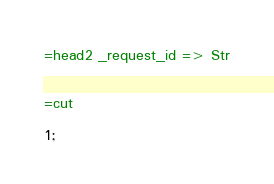<code> <loc_0><loc_0><loc_500><loc_500><_Perl_>=head2 _request_id => Str


=cut

1;</code> 